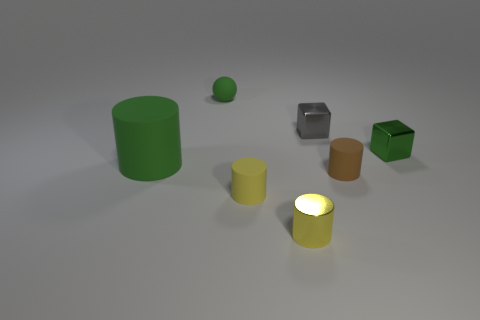What materials do the objects look like they're made of? The objects have different textures suggesting various materials. The large green cylinder and the small green sphere appear rubbery. The cubes, one in green and another with a metallic finish, seem to have harder surfaces, suggesting plastic and metal, respectively. The yellow and brown cylinders have a more matte finish, hinting they might be made of a material like ceramic or plastic. 